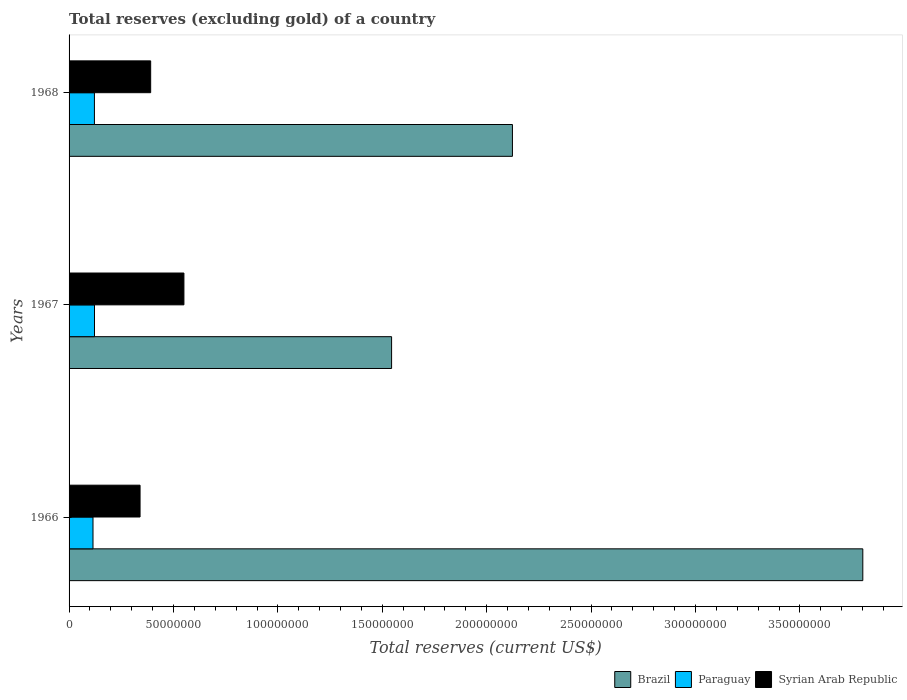How many different coloured bars are there?
Provide a short and direct response. 3. How many groups of bars are there?
Offer a very short reply. 3. Are the number of bars per tick equal to the number of legend labels?
Your answer should be compact. Yes. Are the number of bars on each tick of the Y-axis equal?
Give a very brief answer. Yes. How many bars are there on the 2nd tick from the top?
Provide a short and direct response. 3. How many bars are there on the 1st tick from the bottom?
Your answer should be compact. 3. What is the label of the 2nd group of bars from the top?
Make the answer very short. 1967. What is the total reserves (excluding gold) in Brazil in 1968?
Your answer should be very brief. 2.12e+08. Across all years, what is the maximum total reserves (excluding gold) in Syrian Arab Republic?
Make the answer very short. 5.50e+07. Across all years, what is the minimum total reserves (excluding gold) in Paraguay?
Provide a short and direct response. 1.15e+07. In which year was the total reserves (excluding gold) in Brazil maximum?
Your answer should be compact. 1966. In which year was the total reserves (excluding gold) in Syrian Arab Republic minimum?
Your answer should be very brief. 1966. What is the total total reserves (excluding gold) in Syrian Arab Republic in the graph?
Your answer should be very brief. 1.28e+08. What is the difference between the total reserves (excluding gold) in Paraguay in 1966 and that in 1967?
Provide a succinct answer. -7.20e+05. What is the difference between the total reserves (excluding gold) in Brazil in 1966 and the total reserves (excluding gold) in Paraguay in 1967?
Keep it short and to the point. 3.68e+08. What is the average total reserves (excluding gold) in Brazil per year?
Give a very brief answer. 2.49e+08. In the year 1966, what is the difference between the total reserves (excluding gold) in Syrian Arab Republic and total reserves (excluding gold) in Brazil?
Your answer should be compact. -3.46e+08. What is the ratio of the total reserves (excluding gold) in Paraguay in 1966 to that in 1968?
Provide a succinct answer. 0.94. What is the difference between the highest and the lowest total reserves (excluding gold) in Paraguay?
Offer a terse response. 7.20e+05. In how many years, is the total reserves (excluding gold) in Brazil greater than the average total reserves (excluding gold) in Brazil taken over all years?
Provide a succinct answer. 1. What does the 1st bar from the top in 1967 represents?
Your response must be concise. Syrian Arab Republic. What does the 2nd bar from the bottom in 1968 represents?
Your answer should be compact. Paraguay. Is it the case that in every year, the sum of the total reserves (excluding gold) in Brazil and total reserves (excluding gold) in Syrian Arab Republic is greater than the total reserves (excluding gold) in Paraguay?
Provide a short and direct response. Yes. How many bars are there?
Make the answer very short. 9. What is the difference between two consecutive major ticks on the X-axis?
Provide a succinct answer. 5.00e+07. Does the graph contain any zero values?
Offer a terse response. No. Does the graph contain grids?
Provide a short and direct response. No. Where does the legend appear in the graph?
Provide a succinct answer. Bottom right. How many legend labels are there?
Your answer should be compact. 3. How are the legend labels stacked?
Provide a short and direct response. Horizontal. What is the title of the graph?
Offer a terse response. Total reserves (excluding gold) of a country. What is the label or title of the X-axis?
Make the answer very short. Total reserves (current US$). What is the label or title of the Y-axis?
Provide a short and direct response. Years. What is the Total reserves (current US$) in Brazil in 1966?
Offer a very short reply. 3.80e+08. What is the Total reserves (current US$) in Paraguay in 1966?
Give a very brief answer. 1.15e+07. What is the Total reserves (current US$) of Syrian Arab Republic in 1966?
Provide a succinct answer. 3.40e+07. What is the Total reserves (current US$) in Brazil in 1967?
Provide a short and direct response. 1.54e+08. What is the Total reserves (current US$) of Paraguay in 1967?
Keep it short and to the point. 1.22e+07. What is the Total reserves (current US$) in Syrian Arab Republic in 1967?
Provide a succinct answer. 5.50e+07. What is the Total reserves (current US$) in Brazil in 1968?
Provide a short and direct response. 2.12e+08. What is the Total reserves (current US$) in Paraguay in 1968?
Give a very brief answer. 1.21e+07. What is the Total reserves (current US$) of Syrian Arab Republic in 1968?
Provide a short and direct response. 3.91e+07. Across all years, what is the maximum Total reserves (current US$) in Brazil?
Provide a succinct answer. 3.80e+08. Across all years, what is the maximum Total reserves (current US$) of Paraguay?
Provide a short and direct response. 1.22e+07. Across all years, what is the maximum Total reserves (current US$) of Syrian Arab Republic?
Offer a terse response. 5.50e+07. Across all years, what is the minimum Total reserves (current US$) in Brazil?
Give a very brief answer. 1.54e+08. Across all years, what is the minimum Total reserves (current US$) in Paraguay?
Keep it short and to the point. 1.15e+07. Across all years, what is the minimum Total reserves (current US$) in Syrian Arab Republic?
Provide a short and direct response. 3.40e+07. What is the total Total reserves (current US$) of Brazil in the graph?
Ensure brevity in your answer.  7.47e+08. What is the total Total reserves (current US$) of Paraguay in the graph?
Make the answer very short. 3.58e+07. What is the total Total reserves (current US$) of Syrian Arab Republic in the graph?
Offer a very short reply. 1.28e+08. What is the difference between the Total reserves (current US$) of Brazil in 1966 and that in 1967?
Offer a terse response. 2.26e+08. What is the difference between the Total reserves (current US$) of Paraguay in 1966 and that in 1967?
Give a very brief answer. -7.20e+05. What is the difference between the Total reserves (current US$) of Syrian Arab Republic in 1966 and that in 1967?
Offer a very short reply. -2.10e+07. What is the difference between the Total reserves (current US$) of Brazil in 1966 and that in 1968?
Provide a succinct answer. 1.68e+08. What is the difference between the Total reserves (current US$) in Paraguay in 1966 and that in 1968?
Ensure brevity in your answer.  -6.80e+05. What is the difference between the Total reserves (current US$) in Syrian Arab Republic in 1966 and that in 1968?
Provide a succinct answer. -5.08e+06. What is the difference between the Total reserves (current US$) in Brazil in 1967 and that in 1968?
Offer a very short reply. -5.79e+07. What is the difference between the Total reserves (current US$) of Paraguay in 1967 and that in 1968?
Provide a succinct answer. 4.00e+04. What is the difference between the Total reserves (current US$) of Syrian Arab Republic in 1967 and that in 1968?
Your answer should be very brief. 1.59e+07. What is the difference between the Total reserves (current US$) in Brazil in 1966 and the Total reserves (current US$) in Paraguay in 1967?
Your response must be concise. 3.68e+08. What is the difference between the Total reserves (current US$) in Brazil in 1966 and the Total reserves (current US$) in Syrian Arab Republic in 1967?
Ensure brevity in your answer.  3.25e+08. What is the difference between the Total reserves (current US$) in Paraguay in 1966 and the Total reserves (current US$) in Syrian Arab Republic in 1967?
Your answer should be very brief. -4.35e+07. What is the difference between the Total reserves (current US$) of Brazil in 1966 and the Total reserves (current US$) of Paraguay in 1968?
Make the answer very short. 3.68e+08. What is the difference between the Total reserves (current US$) in Brazil in 1966 and the Total reserves (current US$) in Syrian Arab Republic in 1968?
Provide a succinct answer. 3.41e+08. What is the difference between the Total reserves (current US$) of Paraguay in 1966 and the Total reserves (current US$) of Syrian Arab Republic in 1968?
Your response must be concise. -2.76e+07. What is the difference between the Total reserves (current US$) of Brazil in 1967 and the Total reserves (current US$) of Paraguay in 1968?
Keep it short and to the point. 1.42e+08. What is the difference between the Total reserves (current US$) in Brazil in 1967 and the Total reserves (current US$) in Syrian Arab Republic in 1968?
Ensure brevity in your answer.  1.15e+08. What is the difference between the Total reserves (current US$) of Paraguay in 1967 and the Total reserves (current US$) of Syrian Arab Republic in 1968?
Provide a succinct answer. -2.69e+07. What is the average Total reserves (current US$) in Brazil per year?
Offer a very short reply. 2.49e+08. What is the average Total reserves (current US$) of Paraguay per year?
Make the answer very short. 1.19e+07. What is the average Total reserves (current US$) of Syrian Arab Republic per year?
Offer a very short reply. 4.27e+07. In the year 1966, what is the difference between the Total reserves (current US$) of Brazil and Total reserves (current US$) of Paraguay?
Offer a very short reply. 3.69e+08. In the year 1966, what is the difference between the Total reserves (current US$) in Brazil and Total reserves (current US$) in Syrian Arab Republic?
Give a very brief answer. 3.46e+08. In the year 1966, what is the difference between the Total reserves (current US$) in Paraguay and Total reserves (current US$) in Syrian Arab Republic?
Your answer should be very brief. -2.25e+07. In the year 1967, what is the difference between the Total reserves (current US$) of Brazil and Total reserves (current US$) of Paraguay?
Offer a very short reply. 1.42e+08. In the year 1967, what is the difference between the Total reserves (current US$) of Brazil and Total reserves (current US$) of Syrian Arab Republic?
Your answer should be compact. 9.95e+07. In the year 1967, what is the difference between the Total reserves (current US$) in Paraguay and Total reserves (current US$) in Syrian Arab Republic?
Provide a short and direct response. -4.28e+07. In the year 1968, what is the difference between the Total reserves (current US$) of Brazil and Total reserves (current US$) of Paraguay?
Ensure brevity in your answer.  2.00e+08. In the year 1968, what is the difference between the Total reserves (current US$) of Brazil and Total reserves (current US$) of Syrian Arab Republic?
Make the answer very short. 1.73e+08. In the year 1968, what is the difference between the Total reserves (current US$) in Paraguay and Total reserves (current US$) in Syrian Arab Republic?
Offer a very short reply. -2.69e+07. What is the ratio of the Total reserves (current US$) of Brazil in 1966 to that in 1967?
Your answer should be compact. 2.46. What is the ratio of the Total reserves (current US$) in Paraguay in 1966 to that in 1967?
Ensure brevity in your answer.  0.94. What is the ratio of the Total reserves (current US$) of Syrian Arab Republic in 1966 to that in 1967?
Your response must be concise. 0.62. What is the ratio of the Total reserves (current US$) in Brazil in 1966 to that in 1968?
Your answer should be very brief. 1.79. What is the ratio of the Total reserves (current US$) of Paraguay in 1966 to that in 1968?
Provide a short and direct response. 0.94. What is the ratio of the Total reserves (current US$) of Syrian Arab Republic in 1966 to that in 1968?
Provide a succinct answer. 0.87. What is the ratio of the Total reserves (current US$) in Brazil in 1967 to that in 1968?
Give a very brief answer. 0.73. What is the ratio of the Total reserves (current US$) of Paraguay in 1967 to that in 1968?
Offer a terse response. 1. What is the ratio of the Total reserves (current US$) in Syrian Arab Republic in 1967 to that in 1968?
Ensure brevity in your answer.  1.41. What is the difference between the highest and the second highest Total reserves (current US$) in Brazil?
Your answer should be very brief. 1.68e+08. What is the difference between the highest and the second highest Total reserves (current US$) in Syrian Arab Republic?
Ensure brevity in your answer.  1.59e+07. What is the difference between the highest and the lowest Total reserves (current US$) of Brazil?
Keep it short and to the point. 2.26e+08. What is the difference between the highest and the lowest Total reserves (current US$) of Paraguay?
Your answer should be compact. 7.20e+05. What is the difference between the highest and the lowest Total reserves (current US$) of Syrian Arab Republic?
Make the answer very short. 2.10e+07. 